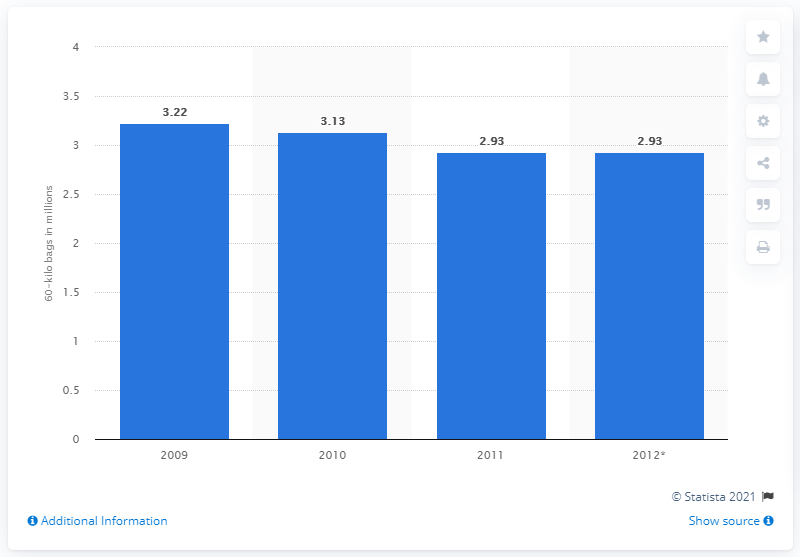List a handful of essential elements in this visual. In 2009, the UK consumed approximately 3.22 bags of coffee. In the United Kingdom, 2.93 bags of coffee were consumed in 2012. 